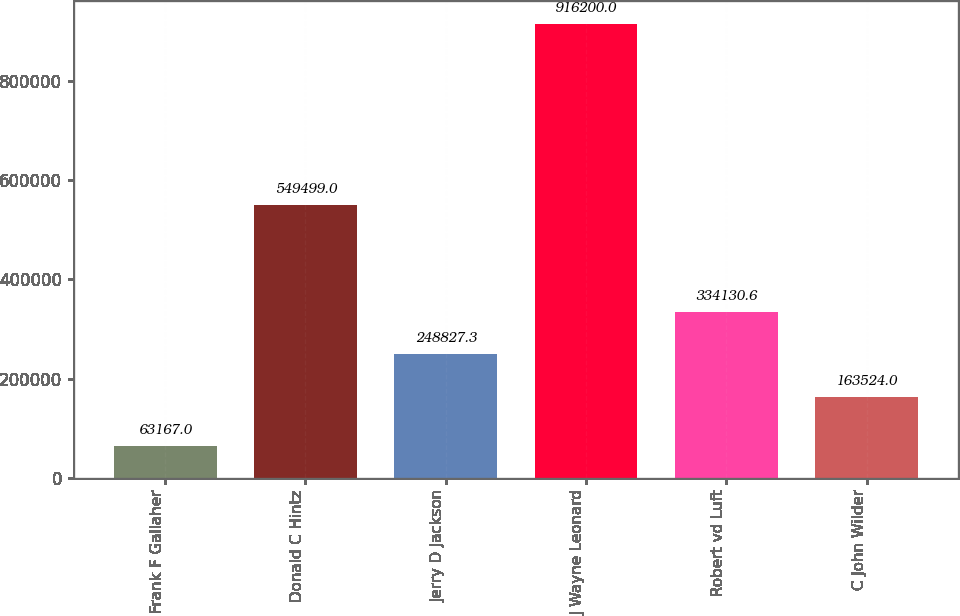Convert chart to OTSL. <chart><loc_0><loc_0><loc_500><loc_500><bar_chart><fcel>Frank F Gallaher<fcel>Donald C Hintz<fcel>Jerry D Jackson<fcel>J Wayne Leonard<fcel>Robert vd Luft<fcel>C John Wilder<nl><fcel>63167<fcel>549499<fcel>248827<fcel>916200<fcel>334131<fcel>163524<nl></chart> 